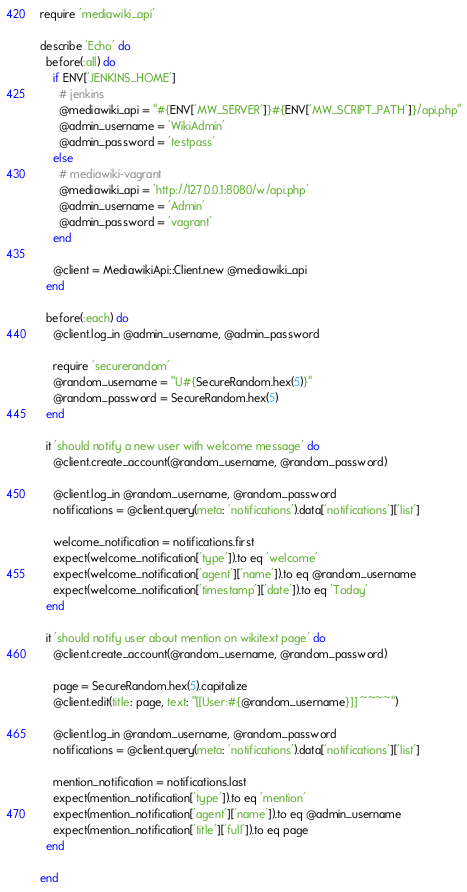<code> <loc_0><loc_0><loc_500><loc_500><_Ruby_>require 'mediawiki_api'

describe 'Echo' do
  before(:all) do
    if ENV['JENKINS_HOME']
      # jenkins
      @mediawiki_api = "#{ENV['MW_SERVER']}#{ENV['MW_SCRIPT_PATH']}/api.php"
      @admin_username = 'WikiAdmin'
      @admin_password = 'testpass'
    else
      # mediawiki-vagrant
      @mediawiki_api = 'http://127.0.0.1:8080/w/api.php'
      @admin_username = 'Admin'
      @admin_password = 'vagrant'
    end

    @client = MediawikiApi::Client.new @mediawiki_api
  end

  before(:each) do
    @client.log_in @admin_username, @admin_password

    require 'securerandom'
    @random_username = "U#{SecureRandom.hex(5)}"
    @random_password = SecureRandom.hex(5)
  end

  it 'should notify a new user with welcome message' do
    @client.create_account(@random_username, @random_password)

    @client.log_in @random_username, @random_password
    notifications = @client.query(meta: 'notifications').data['notifications']['list']

    welcome_notification = notifications.first
    expect(welcome_notification['type']).to eq 'welcome'
    expect(welcome_notification['agent']['name']).to eq @random_username
    expect(welcome_notification['timestamp']['date']).to eq 'Today'
  end

  it 'should notify user about mention on wikitext page' do
    @client.create_account(@random_username, @random_password)

    page = SecureRandom.hex(5).capitalize
    @client.edit(title: page, text: "[[User:#{@random_username}]] ~~~~")

    @client.log_in @random_username, @random_password
    notifications = @client.query(meta: 'notifications').data['notifications']['list']

    mention_notification = notifications.last
    expect(mention_notification['type']).to eq 'mention'
    expect(mention_notification['agent']['name']).to eq @admin_username
    expect(mention_notification['title']['full']).to eq page
  end

end
</code> 